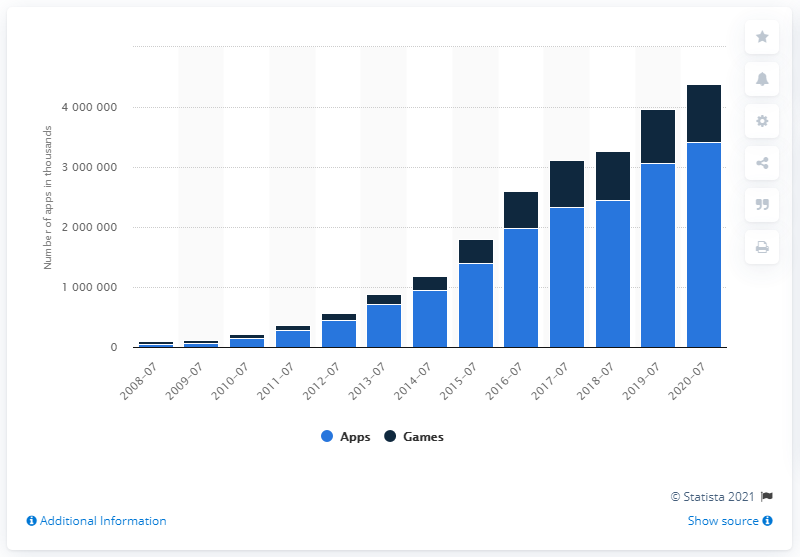List a handful of essential elements in this visual. In 2020, there were approximately 3.42 million non-gaming apps available in the App Store. 